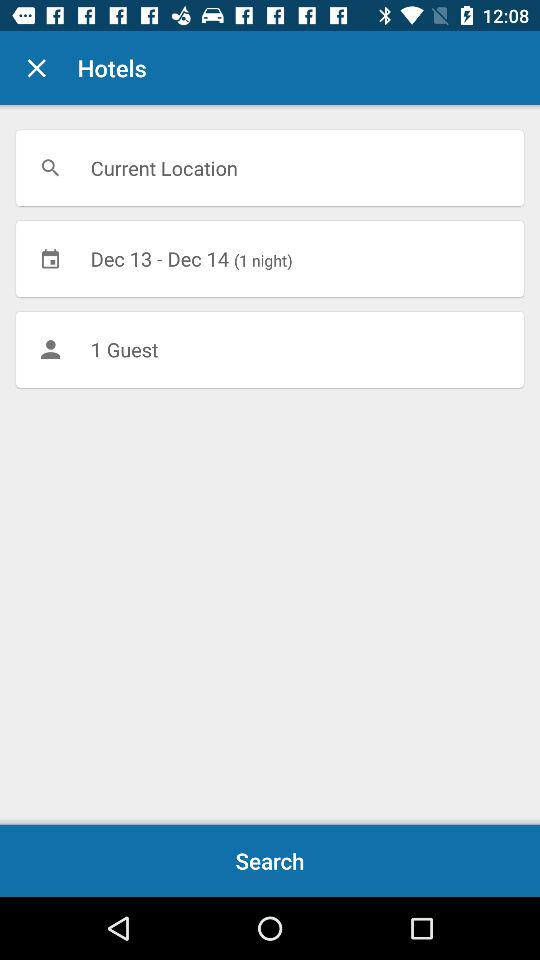For how many nights is the booking being made? The booking is for 1 night. 